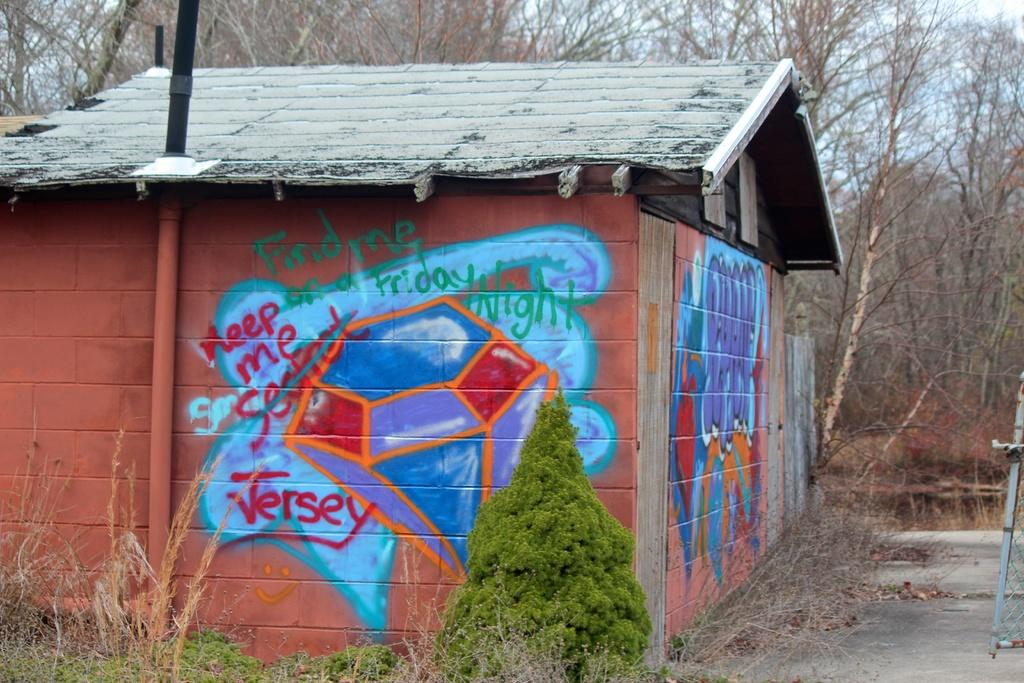What type of structure is visible in the image? There is a house in the image. What is present on the walls of the house? There is graffiti on the walls of the house. What can be seen in the background of the image? There are plants, trees, and the sky visible in the background of the image. What type of canvas is being used to create the graffiti in the image? There is no canvas present in the image; the graffiti is directly on the walls of the house. 